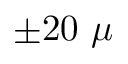Convert formula to latex. <formula><loc_0><loc_0><loc_500><loc_500>\pm 2 0 \mu</formula> 